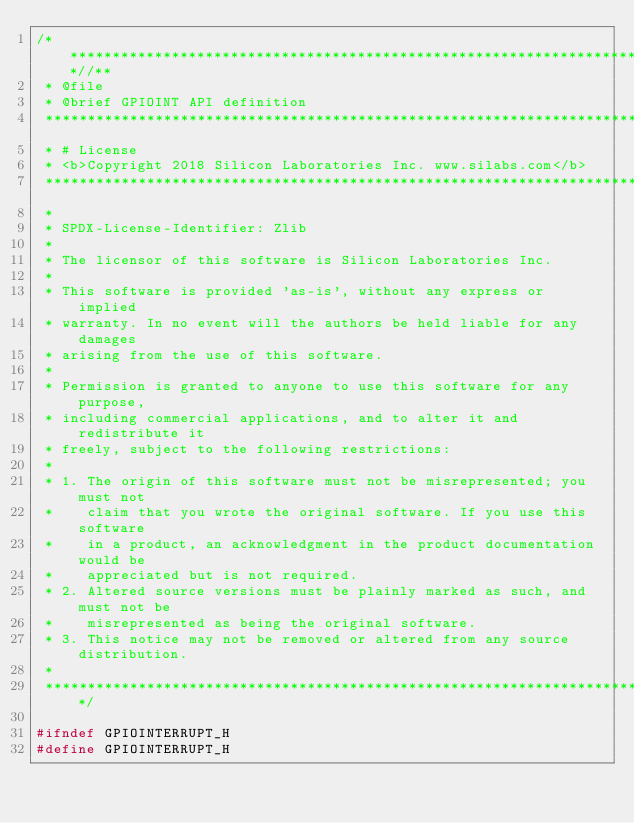<code> <loc_0><loc_0><loc_500><loc_500><_C_>/***************************************************************************//**
 * @file
 * @brief GPIOINT API definition
 *******************************************************************************
 * # License
 * <b>Copyright 2018 Silicon Laboratories Inc. www.silabs.com</b>
 *******************************************************************************
 *
 * SPDX-License-Identifier: Zlib
 *
 * The licensor of this software is Silicon Laboratories Inc.
 *
 * This software is provided 'as-is', without any express or implied
 * warranty. In no event will the authors be held liable for any damages
 * arising from the use of this software.
 *
 * Permission is granted to anyone to use this software for any purpose,
 * including commercial applications, and to alter it and redistribute it
 * freely, subject to the following restrictions:
 *
 * 1. The origin of this software must not be misrepresented; you must not
 *    claim that you wrote the original software. If you use this software
 *    in a product, an acknowledgment in the product documentation would be
 *    appreciated but is not required.
 * 2. Altered source versions must be plainly marked as such, and must not be
 *    misrepresented as being the original software.
 * 3. This notice may not be removed or altered from any source distribution.
 *
 ******************************************************************************/

#ifndef GPIOINTERRUPT_H
#define GPIOINTERRUPT_H
</code> 